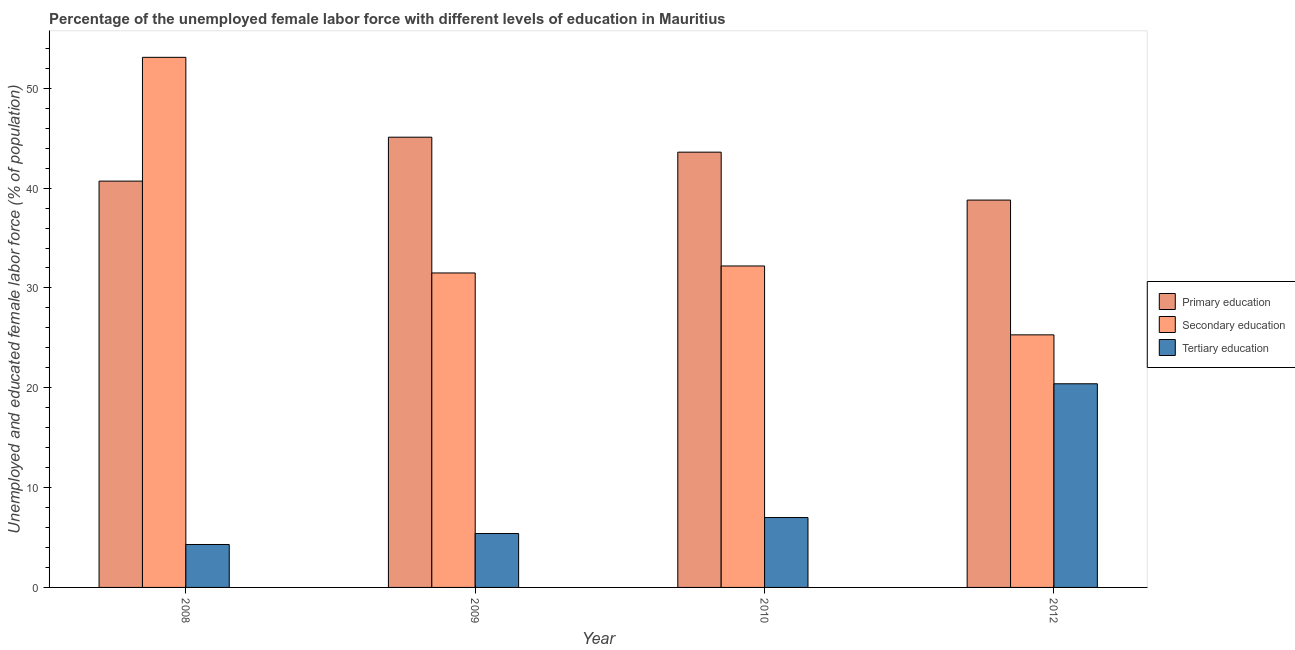How many groups of bars are there?
Your answer should be compact. 4. Are the number of bars per tick equal to the number of legend labels?
Keep it short and to the point. Yes. Are the number of bars on each tick of the X-axis equal?
Keep it short and to the point. Yes. What is the label of the 4th group of bars from the left?
Make the answer very short. 2012. What is the percentage of female labor force who received primary education in 2010?
Your answer should be compact. 43.6. Across all years, what is the maximum percentage of female labor force who received tertiary education?
Keep it short and to the point. 20.4. Across all years, what is the minimum percentage of female labor force who received primary education?
Ensure brevity in your answer.  38.8. In which year was the percentage of female labor force who received tertiary education minimum?
Provide a short and direct response. 2008. What is the total percentage of female labor force who received primary education in the graph?
Give a very brief answer. 168.2. What is the difference between the percentage of female labor force who received secondary education in 2010 and that in 2012?
Make the answer very short. 6.9. What is the difference between the percentage of female labor force who received secondary education in 2010 and the percentage of female labor force who received tertiary education in 2008?
Your answer should be very brief. -20.9. What is the average percentage of female labor force who received secondary education per year?
Keep it short and to the point. 35.52. In how many years, is the percentage of female labor force who received tertiary education greater than 40 %?
Keep it short and to the point. 0. What is the ratio of the percentage of female labor force who received secondary education in 2008 to that in 2010?
Your response must be concise. 1.65. What is the difference between the highest and the second highest percentage of female labor force who received tertiary education?
Provide a short and direct response. 13.4. What is the difference between the highest and the lowest percentage of female labor force who received secondary education?
Ensure brevity in your answer.  27.8. In how many years, is the percentage of female labor force who received primary education greater than the average percentage of female labor force who received primary education taken over all years?
Make the answer very short. 2. Is the sum of the percentage of female labor force who received tertiary education in 2008 and 2009 greater than the maximum percentage of female labor force who received primary education across all years?
Keep it short and to the point. No. What does the 3rd bar from the left in 2012 represents?
Your response must be concise. Tertiary education. What does the 3rd bar from the right in 2009 represents?
Your response must be concise. Primary education. How many bars are there?
Your response must be concise. 12. Are all the bars in the graph horizontal?
Provide a succinct answer. No. Are the values on the major ticks of Y-axis written in scientific E-notation?
Ensure brevity in your answer.  No. Does the graph contain any zero values?
Provide a succinct answer. No. Does the graph contain grids?
Offer a terse response. No. How many legend labels are there?
Keep it short and to the point. 3. What is the title of the graph?
Make the answer very short. Percentage of the unemployed female labor force with different levels of education in Mauritius. What is the label or title of the Y-axis?
Keep it short and to the point. Unemployed and educated female labor force (% of population). What is the Unemployed and educated female labor force (% of population) of Primary education in 2008?
Keep it short and to the point. 40.7. What is the Unemployed and educated female labor force (% of population) in Secondary education in 2008?
Provide a short and direct response. 53.1. What is the Unemployed and educated female labor force (% of population) of Tertiary education in 2008?
Your response must be concise. 4.3. What is the Unemployed and educated female labor force (% of population) of Primary education in 2009?
Offer a terse response. 45.1. What is the Unemployed and educated female labor force (% of population) in Secondary education in 2009?
Ensure brevity in your answer.  31.5. What is the Unemployed and educated female labor force (% of population) of Tertiary education in 2009?
Ensure brevity in your answer.  5.4. What is the Unemployed and educated female labor force (% of population) in Primary education in 2010?
Your answer should be compact. 43.6. What is the Unemployed and educated female labor force (% of population) in Secondary education in 2010?
Your answer should be very brief. 32.2. What is the Unemployed and educated female labor force (% of population) of Primary education in 2012?
Your answer should be compact. 38.8. What is the Unemployed and educated female labor force (% of population) of Secondary education in 2012?
Provide a succinct answer. 25.3. What is the Unemployed and educated female labor force (% of population) in Tertiary education in 2012?
Offer a very short reply. 20.4. Across all years, what is the maximum Unemployed and educated female labor force (% of population) in Primary education?
Offer a terse response. 45.1. Across all years, what is the maximum Unemployed and educated female labor force (% of population) in Secondary education?
Provide a succinct answer. 53.1. Across all years, what is the maximum Unemployed and educated female labor force (% of population) in Tertiary education?
Your response must be concise. 20.4. Across all years, what is the minimum Unemployed and educated female labor force (% of population) in Primary education?
Your response must be concise. 38.8. Across all years, what is the minimum Unemployed and educated female labor force (% of population) in Secondary education?
Offer a very short reply. 25.3. Across all years, what is the minimum Unemployed and educated female labor force (% of population) of Tertiary education?
Make the answer very short. 4.3. What is the total Unemployed and educated female labor force (% of population) of Primary education in the graph?
Make the answer very short. 168.2. What is the total Unemployed and educated female labor force (% of population) in Secondary education in the graph?
Offer a very short reply. 142.1. What is the total Unemployed and educated female labor force (% of population) in Tertiary education in the graph?
Offer a terse response. 37.1. What is the difference between the Unemployed and educated female labor force (% of population) of Primary education in 2008 and that in 2009?
Offer a terse response. -4.4. What is the difference between the Unemployed and educated female labor force (% of population) in Secondary education in 2008 and that in 2009?
Make the answer very short. 21.6. What is the difference between the Unemployed and educated female labor force (% of population) in Tertiary education in 2008 and that in 2009?
Your answer should be very brief. -1.1. What is the difference between the Unemployed and educated female labor force (% of population) in Secondary education in 2008 and that in 2010?
Offer a terse response. 20.9. What is the difference between the Unemployed and educated female labor force (% of population) of Tertiary education in 2008 and that in 2010?
Your response must be concise. -2.7. What is the difference between the Unemployed and educated female labor force (% of population) of Secondary education in 2008 and that in 2012?
Keep it short and to the point. 27.8. What is the difference between the Unemployed and educated female labor force (% of population) in Tertiary education in 2008 and that in 2012?
Your answer should be compact. -16.1. What is the difference between the Unemployed and educated female labor force (% of population) in Secondary education in 2009 and that in 2012?
Provide a short and direct response. 6.2. What is the difference between the Unemployed and educated female labor force (% of population) of Tertiary education in 2009 and that in 2012?
Make the answer very short. -15. What is the difference between the Unemployed and educated female labor force (% of population) of Primary education in 2010 and that in 2012?
Your response must be concise. 4.8. What is the difference between the Unemployed and educated female labor force (% of population) of Secondary education in 2010 and that in 2012?
Your answer should be compact. 6.9. What is the difference between the Unemployed and educated female labor force (% of population) in Tertiary education in 2010 and that in 2012?
Ensure brevity in your answer.  -13.4. What is the difference between the Unemployed and educated female labor force (% of population) in Primary education in 2008 and the Unemployed and educated female labor force (% of population) in Tertiary education in 2009?
Offer a very short reply. 35.3. What is the difference between the Unemployed and educated female labor force (% of population) in Secondary education in 2008 and the Unemployed and educated female labor force (% of population) in Tertiary education in 2009?
Keep it short and to the point. 47.7. What is the difference between the Unemployed and educated female labor force (% of population) in Primary education in 2008 and the Unemployed and educated female labor force (% of population) in Secondary education in 2010?
Your answer should be compact. 8.5. What is the difference between the Unemployed and educated female labor force (% of population) of Primary education in 2008 and the Unemployed and educated female labor force (% of population) of Tertiary education in 2010?
Provide a succinct answer. 33.7. What is the difference between the Unemployed and educated female labor force (% of population) of Secondary education in 2008 and the Unemployed and educated female labor force (% of population) of Tertiary education in 2010?
Provide a succinct answer. 46.1. What is the difference between the Unemployed and educated female labor force (% of population) in Primary education in 2008 and the Unemployed and educated female labor force (% of population) in Secondary education in 2012?
Provide a succinct answer. 15.4. What is the difference between the Unemployed and educated female labor force (% of population) of Primary education in 2008 and the Unemployed and educated female labor force (% of population) of Tertiary education in 2012?
Provide a short and direct response. 20.3. What is the difference between the Unemployed and educated female labor force (% of population) in Secondary education in 2008 and the Unemployed and educated female labor force (% of population) in Tertiary education in 2012?
Offer a very short reply. 32.7. What is the difference between the Unemployed and educated female labor force (% of population) of Primary education in 2009 and the Unemployed and educated female labor force (% of population) of Tertiary education in 2010?
Your answer should be very brief. 38.1. What is the difference between the Unemployed and educated female labor force (% of population) in Primary education in 2009 and the Unemployed and educated female labor force (% of population) in Secondary education in 2012?
Offer a terse response. 19.8. What is the difference between the Unemployed and educated female labor force (% of population) in Primary education in 2009 and the Unemployed and educated female labor force (% of population) in Tertiary education in 2012?
Your response must be concise. 24.7. What is the difference between the Unemployed and educated female labor force (% of population) in Primary education in 2010 and the Unemployed and educated female labor force (% of population) in Secondary education in 2012?
Your answer should be compact. 18.3. What is the difference between the Unemployed and educated female labor force (% of population) of Primary education in 2010 and the Unemployed and educated female labor force (% of population) of Tertiary education in 2012?
Keep it short and to the point. 23.2. What is the difference between the Unemployed and educated female labor force (% of population) in Secondary education in 2010 and the Unemployed and educated female labor force (% of population) in Tertiary education in 2012?
Your response must be concise. 11.8. What is the average Unemployed and educated female labor force (% of population) in Primary education per year?
Provide a succinct answer. 42.05. What is the average Unemployed and educated female labor force (% of population) of Secondary education per year?
Your response must be concise. 35.52. What is the average Unemployed and educated female labor force (% of population) of Tertiary education per year?
Offer a very short reply. 9.28. In the year 2008, what is the difference between the Unemployed and educated female labor force (% of population) in Primary education and Unemployed and educated female labor force (% of population) in Secondary education?
Make the answer very short. -12.4. In the year 2008, what is the difference between the Unemployed and educated female labor force (% of population) in Primary education and Unemployed and educated female labor force (% of population) in Tertiary education?
Provide a short and direct response. 36.4. In the year 2008, what is the difference between the Unemployed and educated female labor force (% of population) in Secondary education and Unemployed and educated female labor force (% of population) in Tertiary education?
Make the answer very short. 48.8. In the year 2009, what is the difference between the Unemployed and educated female labor force (% of population) of Primary education and Unemployed and educated female labor force (% of population) of Secondary education?
Provide a succinct answer. 13.6. In the year 2009, what is the difference between the Unemployed and educated female labor force (% of population) in Primary education and Unemployed and educated female labor force (% of population) in Tertiary education?
Offer a very short reply. 39.7. In the year 2009, what is the difference between the Unemployed and educated female labor force (% of population) of Secondary education and Unemployed and educated female labor force (% of population) of Tertiary education?
Give a very brief answer. 26.1. In the year 2010, what is the difference between the Unemployed and educated female labor force (% of population) of Primary education and Unemployed and educated female labor force (% of population) of Tertiary education?
Make the answer very short. 36.6. In the year 2010, what is the difference between the Unemployed and educated female labor force (% of population) of Secondary education and Unemployed and educated female labor force (% of population) of Tertiary education?
Offer a terse response. 25.2. In the year 2012, what is the difference between the Unemployed and educated female labor force (% of population) in Primary education and Unemployed and educated female labor force (% of population) in Secondary education?
Keep it short and to the point. 13.5. In the year 2012, what is the difference between the Unemployed and educated female labor force (% of population) in Secondary education and Unemployed and educated female labor force (% of population) in Tertiary education?
Ensure brevity in your answer.  4.9. What is the ratio of the Unemployed and educated female labor force (% of population) of Primary education in 2008 to that in 2009?
Offer a terse response. 0.9. What is the ratio of the Unemployed and educated female labor force (% of population) of Secondary education in 2008 to that in 2009?
Offer a very short reply. 1.69. What is the ratio of the Unemployed and educated female labor force (% of population) in Tertiary education in 2008 to that in 2009?
Offer a very short reply. 0.8. What is the ratio of the Unemployed and educated female labor force (% of population) in Primary education in 2008 to that in 2010?
Make the answer very short. 0.93. What is the ratio of the Unemployed and educated female labor force (% of population) of Secondary education in 2008 to that in 2010?
Offer a terse response. 1.65. What is the ratio of the Unemployed and educated female labor force (% of population) in Tertiary education in 2008 to that in 2010?
Your answer should be very brief. 0.61. What is the ratio of the Unemployed and educated female labor force (% of population) in Primary education in 2008 to that in 2012?
Your answer should be very brief. 1.05. What is the ratio of the Unemployed and educated female labor force (% of population) of Secondary education in 2008 to that in 2012?
Your response must be concise. 2.1. What is the ratio of the Unemployed and educated female labor force (% of population) of Tertiary education in 2008 to that in 2012?
Offer a very short reply. 0.21. What is the ratio of the Unemployed and educated female labor force (% of population) in Primary education in 2009 to that in 2010?
Provide a succinct answer. 1.03. What is the ratio of the Unemployed and educated female labor force (% of population) in Secondary education in 2009 to that in 2010?
Provide a succinct answer. 0.98. What is the ratio of the Unemployed and educated female labor force (% of population) in Tertiary education in 2009 to that in 2010?
Your response must be concise. 0.77. What is the ratio of the Unemployed and educated female labor force (% of population) of Primary education in 2009 to that in 2012?
Your answer should be compact. 1.16. What is the ratio of the Unemployed and educated female labor force (% of population) of Secondary education in 2009 to that in 2012?
Offer a very short reply. 1.25. What is the ratio of the Unemployed and educated female labor force (% of population) in Tertiary education in 2009 to that in 2012?
Your answer should be compact. 0.26. What is the ratio of the Unemployed and educated female labor force (% of population) in Primary education in 2010 to that in 2012?
Provide a succinct answer. 1.12. What is the ratio of the Unemployed and educated female labor force (% of population) of Secondary education in 2010 to that in 2012?
Provide a succinct answer. 1.27. What is the ratio of the Unemployed and educated female labor force (% of population) of Tertiary education in 2010 to that in 2012?
Provide a succinct answer. 0.34. What is the difference between the highest and the second highest Unemployed and educated female labor force (% of population) in Primary education?
Make the answer very short. 1.5. What is the difference between the highest and the second highest Unemployed and educated female labor force (% of population) in Secondary education?
Give a very brief answer. 20.9. What is the difference between the highest and the lowest Unemployed and educated female labor force (% of population) of Primary education?
Your answer should be very brief. 6.3. What is the difference between the highest and the lowest Unemployed and educated female labor force (% of population) in Secondary education?
Your answer should be compact. 27.8. What is the difference between the highest and the lowest Unemployed and educated female labor force (% of population) of Tertiary education?
Provide a succinct answer. 16.1. 